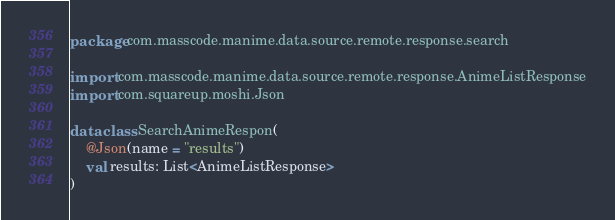<code> <loc_0><loc_0><loc_500><loc_500><_Kotlin_>package com.masscode.manime.data.source.remote.response.search

import com.masscode.manime.data.source.remote.response.AnimeListResponse
import com.squareup.moshi.Json

data class SearchAnimeRespon(
    @Json(name = "results")
    val results: List<AnimeListResponse>
)</code> 